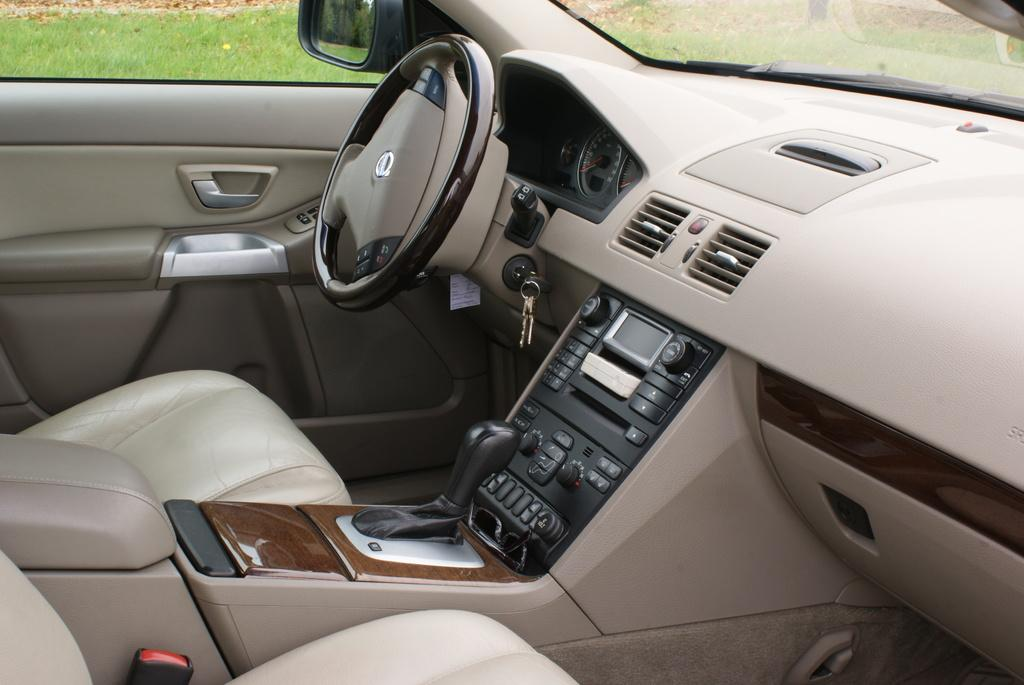What type of vehicle is shown in the image? The image shows an inside view of a car. What is the primary control mechanism in the car? There is a steering wheel in the car. What is used to start the car? Keys are visible in the image. What type of controls are present in the car? There are buttons in the car. What feature is available for temperature control in the car? The car has an air conditioning system (AC). What can be seen outside the car through the glass? Grass is visible through the car's glass. What type of poison is being used to control the railway in the image? There is no railway or poison present in the image. 